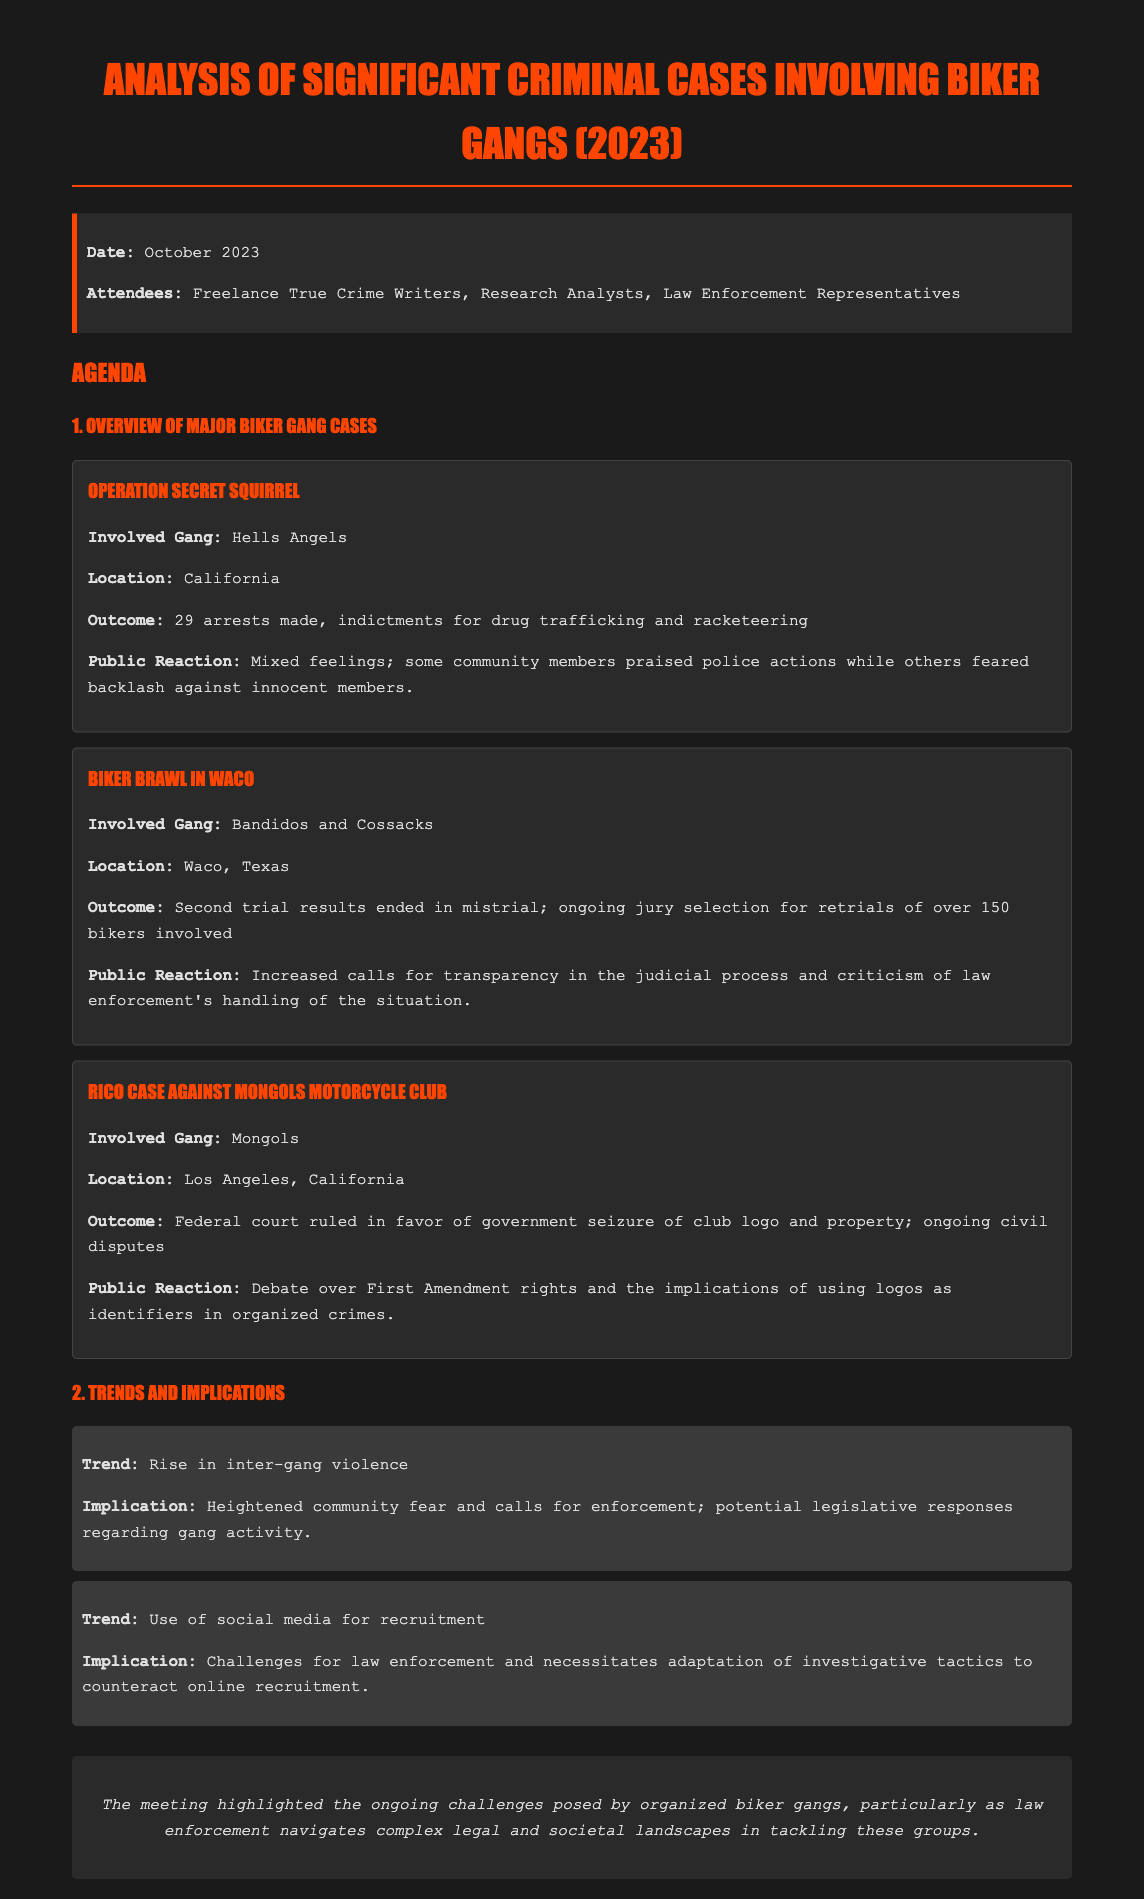what was the date of the meeting? The date mentioned in the document is explicitly stated at the beginning under the information section.
Answer: October 2023 how many arrests were made in Operation Secret Squirrel? The document provides specific details about the number of arrests made during Operation Secret Squirrel.
Answer: 29 arrests which gangs were involved in the Waco brawl? The document lists the gangs involved in the biker brawl in Waco, Texas.
Answer: Bandidos and Cossacks what was the outcome of the RICO case against the Mongols? The document describes the decision made by the federal court regarding the RICO case.
Answer: Government seizure of club logo and property what trend is indicated related to inter-gang violence? The document highlights a specific trend regarding inter-gang violence that has implications for the community.
Answer: Rise in inter-gang violence what public reaction followed the Waco brawl? Insights into public sentiment regarding the handling of the biker brawl situation are detailed in the document.
Answer: Increased calls for transparency who were the attendees of the meeting? The document lists the participants in the meeting held for discussing biker gang criminal cases.
Answer: Freelance True Crime Writers, Research Analysts, Law Enforcement Representatives what implications arose from the recruitment trend on social media? The document mentions the challenges that law enforcement faces due to the research trend discussed.
Answer: Necessitates adaptation of investigative tactics 